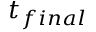Convert formula to latex. <formula><loc_0><loc_0><loc_500><loc_500>t _ { f i n a l }</formula> 